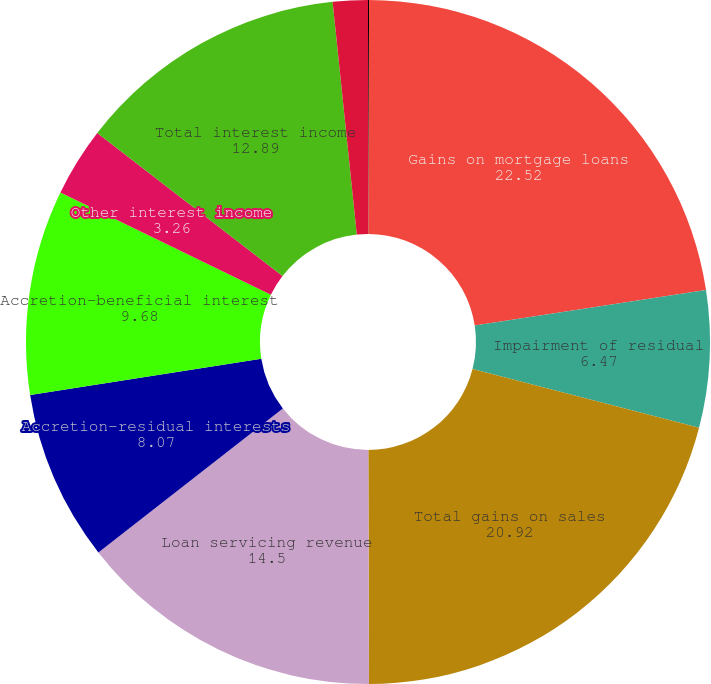Convert chart. <chart><loc_0><loc_0><loc_500><loc_500><pie_chart><fcel>Year ended April 30<fcel>Gains on mortgage loans<fcel>Impairment of residual<fcel>Total gains on sales<fcel>Loan servicing revenue<fcel>Accretion-residual interests<fcel>Accretion-beneficial interest<fcel>Other interest income<fcel>Total interest income<fcel>Other<nl><fcel>0.05%<fcel>22.52%<fcel>6.47%<fcel>20.92%<fcel>14.5%<fcel>8.07%<fcel>9.68%<fcel>3.26%<fcel>12.89%<fcel>1.65%<nl></chart> 